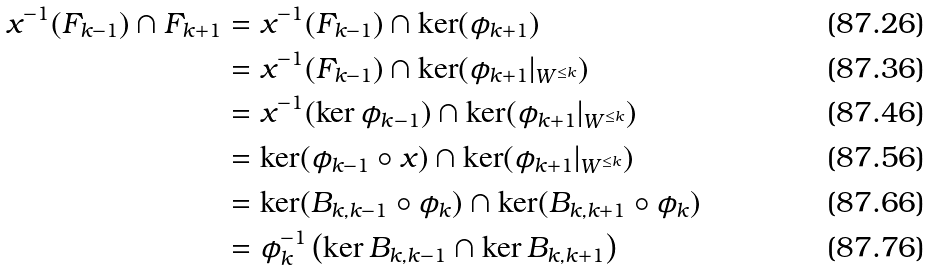<formula> <loc_0><loc_0><loc_500><loc_500>x ^ { - 1 } ( F _ { k - 1 } ) \cap F _ { k + 1 } & = x ^ { - 1 } ( F _ { k - 1 } ) \cap \ker ( \phi _ { k + 1 } ) \\ & = x ^ { - 1 } ( F _ { k - 1 } ) \cap \ker ( \phi _ { k + 1 } | _ { W ^ { \leq k } } ) \\ & = x ^ { - 1 } ( \ker \phi _ { k - 1 } ) \cap \ker ( \phi _ { k + 1 } | _ { W ^ { \leq k } } ) \\ & = \ker ( \phi _ { k - 1 } \circ x ) \cap \ker ( \phi _ { k + 1 } | _ { W ^ { \leq k } } ) \\ & = \ker ( B _ { k , k - 1 } \circ \phi _ { k } ) \cap \ker ( B _ { k , k + 1 } \circ \phi _ { k } ) \\ & = \phi _ { k } ^ { - 1 } \left ( \ker B _ { k , k - 1 } \cap \ker B _ { k , k + 1 } \right )</formula> 